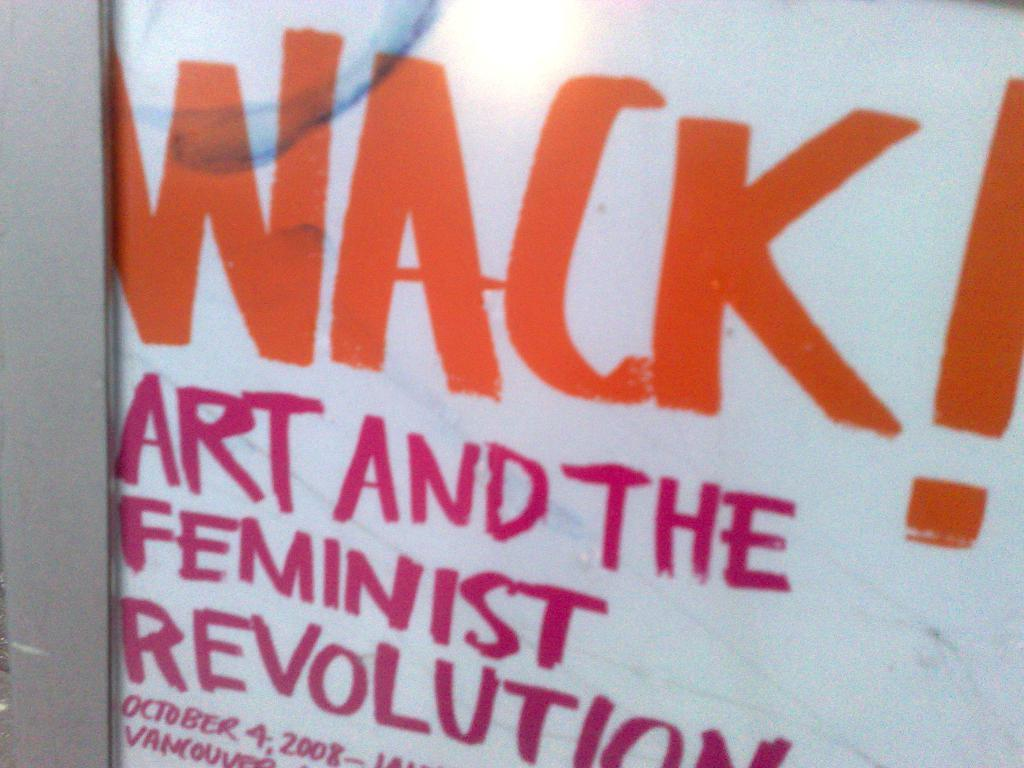<image>
Give a short and clear explanation of the subsequent image. A sign says Wack for art and the feminist revolution. 